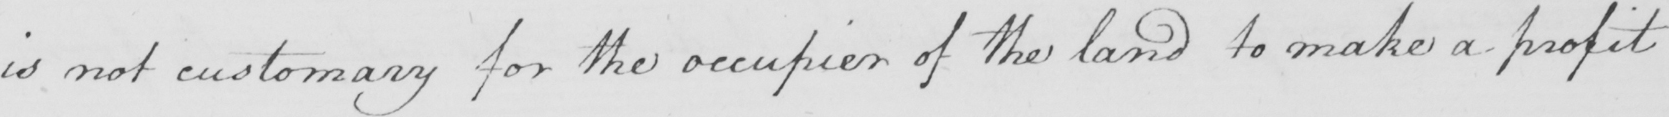Please transcribe the handwritten text in this image. is not customary for the occupier of the land to make a profit 